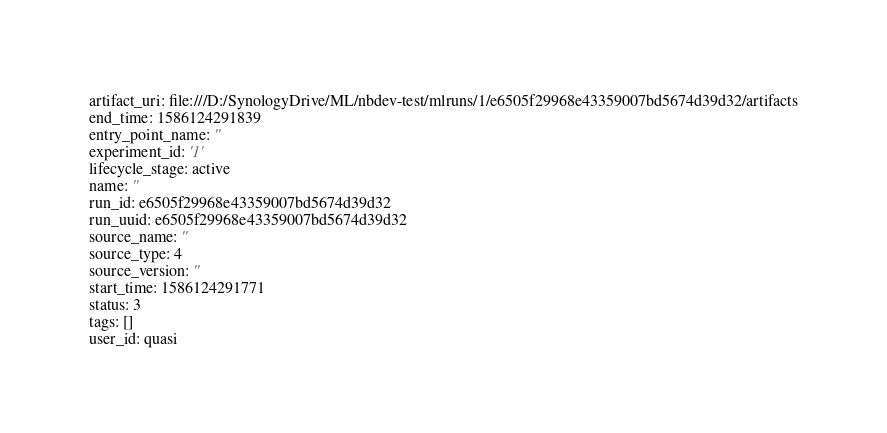Convert code to text. <code><loc_0><loc_0><loc_500><loc_500><_YAML_>artifact_uri: file:///D:/SynologyDrive/ML/nbdev-test/mlruns/1/e6505f29968e43359007bd5674d39d32/artifacts
end_time: 1586124291839
entry_point_name: ''
experiment_id: '1'
lifecycle_stage: active
name: ''
run_id: e6505f29968e43359007bd5674d39d32
run_uuid: e6505f29968e43359007bd5674d39d32
source_name: ''
source_type: 4
source_version: ''
start_time: 1586124291771
status: 3
tags: []
user_id: quasi
</code> 